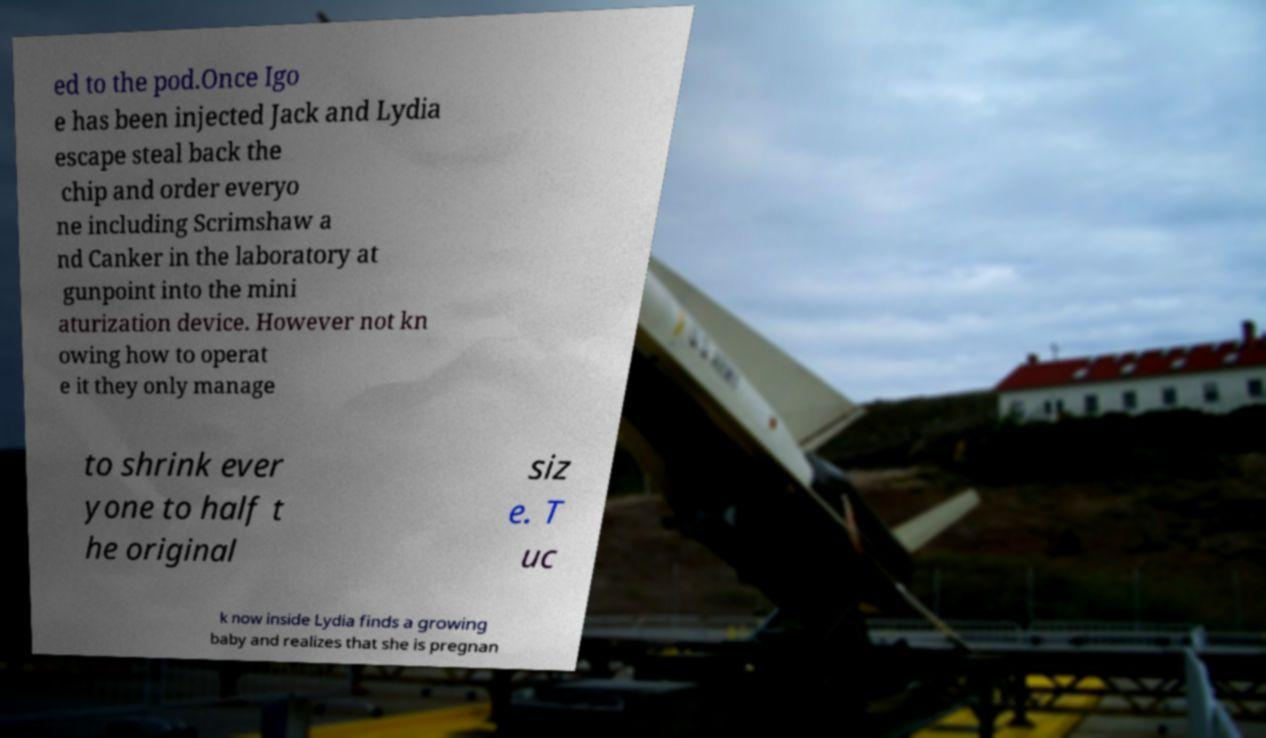I need the written content from this picture converted into text. Can you do that? ed to the pod.Once Igo e has been injected Jack and Lydia escape steal back the chip and order everyo ne including Scrimshaw a nd Canker in the laboratory at gunpoint into the mini aturization device. However not kn owing how to operat e it they only manage to shrink ever yone to half t he original siz e. T uc k now inside Lydia finds a growing baby and realizes that she is pregnan 